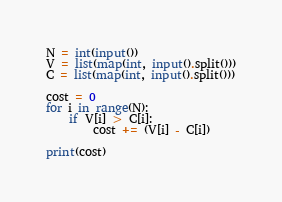<code> <loc_0><loc_0><loc_500><loc_500><_Python_>N = int(input())
V = list(map(int, input().split()))
C = list(map(int, input().split()))

cost = 0
for i in range(N):
    if V[i] > C[i]:
        cost += (V[i] - C[i])

print(cost)</code> 